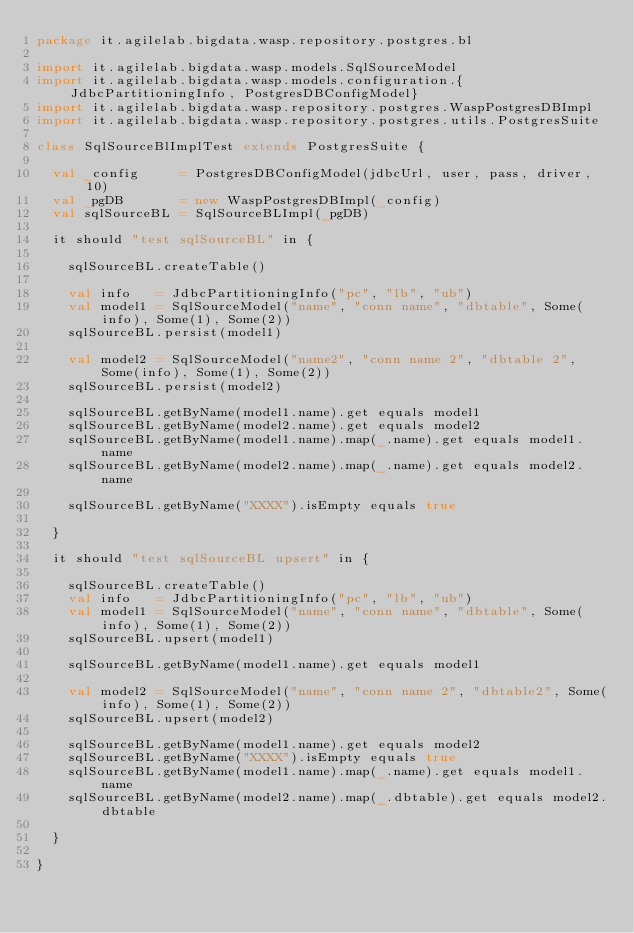<code> <loc_0><loc_0><loc_500><loc_500><_Scala_>package it.agilelab.bigdata.wasp.repository.postgres.bl

import it.agilelab.bigdata.wasp.models.SqlSourceModel
import it.agilelab.bigdata.wasp.models.configuration.{JdbcPartitioningInfo, PostgresDBConfigModel}
import it.agilelab.bigdata.wasp.repository.postgres.WaspPostgresDBImpl
import it.agilelab.bigdata.wasp.repository.postgres.utils.PostgresSuite

class SqlSourceBlImplTest extends PostgresSuite {

  val _config     = PostgresDBConfigModel(jdbcUrl, user, pass, driver, 10)
  val _pgDB       = new WaspPostgresDBImpl(_config)
  val sqlSourceBL = SqlSourceBLImpl(_pgDB)

  it should "test sqlSourceBL" in {

    sqlSourceBL.createTable()

    val info   = JdbcPartitioningInfo("pc", "lb", "ub")
    val model1 = SqlSourceModel("name", "conn name", "dbtable", Some(info), Some(1), Some(2))
    sqlSourceBL.persist(model1)

    val model2 = SqlSourceModel("name2", "conn name 2", "dbtable 2", Some(info), Some(1), Some(2))
    sqlSourceBL.persist(model2)

    sqlSourceBL.getByName(model1.name).get equals model1
    sqlSourceBL.getByName(model2.name).get equals model2
    sqlSourceBL.getByName(model1.name).map(_.name).get equals model1.name
    sqlSourceBL.getByName(model2.name).map(_.name).get equals model2.name

    sqlSourceBL.getByName("XXXX").isEmpty equals true

  }

  it should "test sqlSourceBL upsert" in {

    sqlSourceBL.createTable()
    val info   = JdbcPartitioningInfo("pc", "lb", "ub")
    val model1 = SqlSourceModel("name", "conn name", "dbtable", Some(info), Some(1), Some(2))
    sqlSourceBL.upsert(model1)

    sqlSourceBL.getByName(model1.name).get equals model1

    val model2 = SqlSourceModel("name", "conn name 2", "dbtable2", Some(info), Some(1), Some(2))
    sqlSourceBL.upsert(model2)

    sqlSourceBL.getByName(model1.name).get equals model2
    sqlSourceBL.getByName("XXXX").isEmpty equals true
    sqlSourceBL.getByName(model1.name).map(_.name).get equals model1.name
    sqlSourceBL.getByName(model2.name).map(_.dbtable).get equals model2.dbtable

  }

}
</code> 